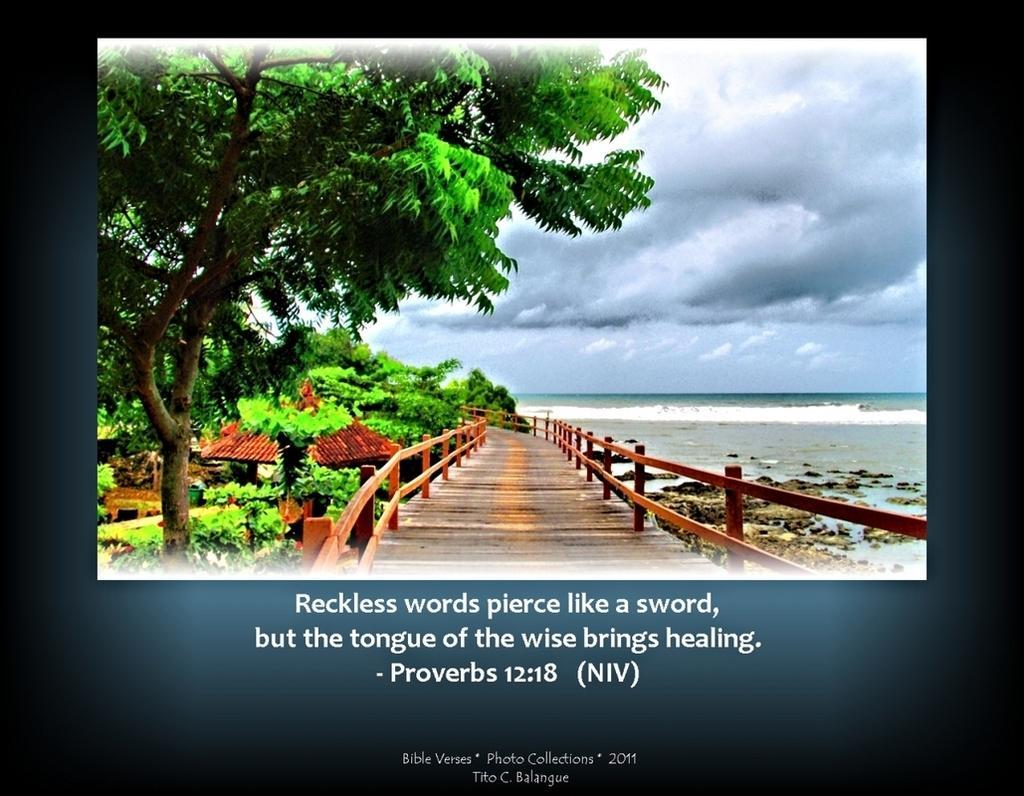How would you summarize this image in a sentence or two? In this image, we can see a poster. Here there is a picture. In this picture, we can see trees, house, walkway, railing and sea. Background there is a cloudy sky. At the bottom of the image, we can see some text. 